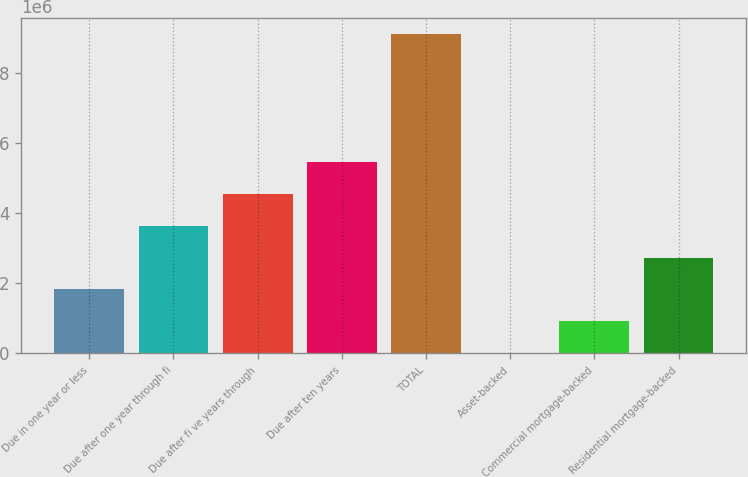<chart> <loc_0><loc_0><loc_500><loc_500><bar_chart><fcel>Due in one year or less<fcel>Due after one year through fi<fcel>Due after fi ve years through<fcel>Due after ten years<fcel>TOTAL<fcel>Asset-backed<fcel>Commercial mortgage-backed<fcel>Residential mortgage-backed<nl><fcel>1.82079e+06<fcel>3.63766e+06<fcel>4.54609e+06<fcel>5.45453e+06<fcel>9.08827e+06<fcel>3917<fcel>912352<fcel>2.72922e+06<nl></chart> 